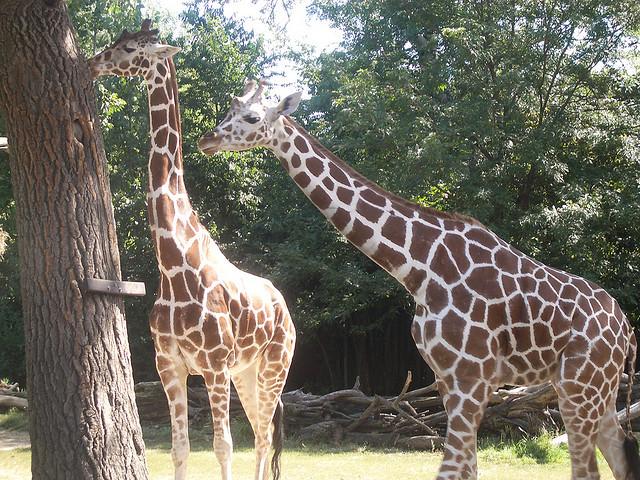Which giraffe is taller?
Keep it brief. Left. Is this a zoo?
Be succinct. Yes. How many animals are pictured here?
Concise answer only. 2. Is the giraffe eating the tree?
Quick response, please. No. IS the giraffe standing straight up?
Be succinct. Yes. Are the giraffes looking at each other?
Answer briefly. No. How many giraffes are seen?
Keep it brief. 2. 